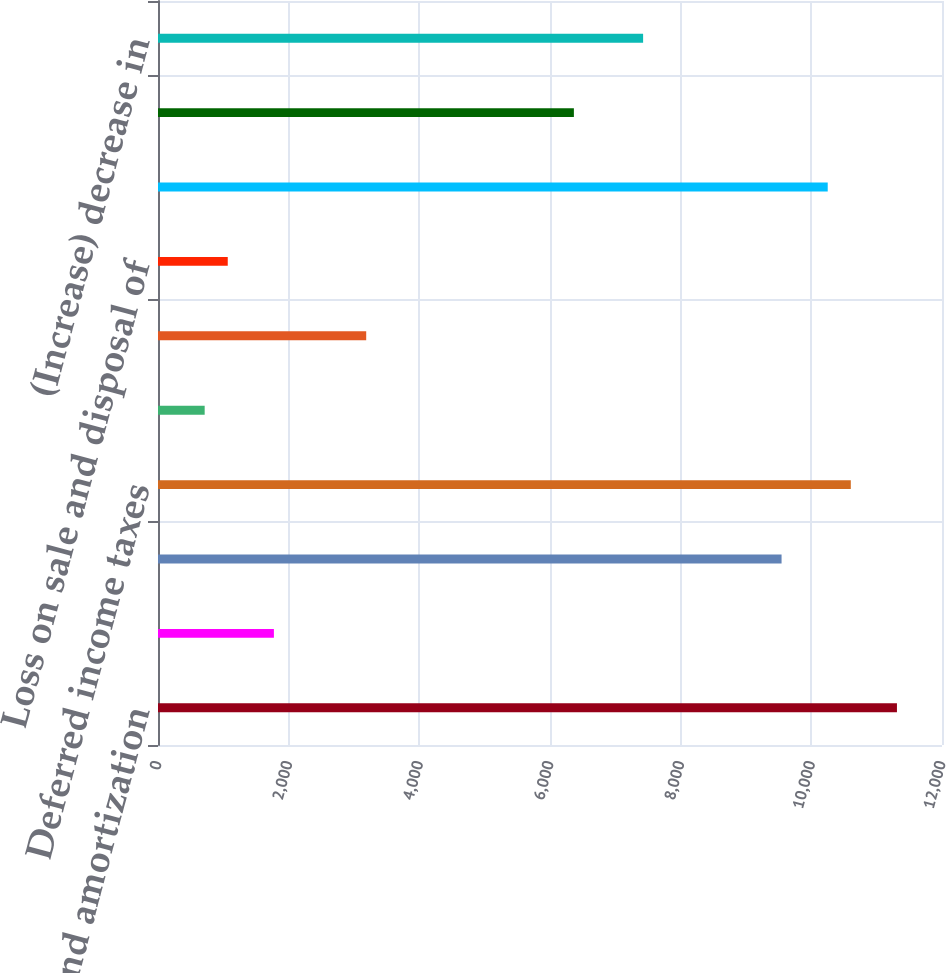Convert chart to OTSL. <chart><loc_0><loc_0><loc_500><loc_500><bar_chart><fcel>Depreciation and amortization<fcel>Loss (gain) on disposal and<fcel>Impairment expenses<fcel>Deferred income taxes<fcel>Provisions for contingencies<fcel>Loss on extinguishment of debt<fcel>Loss on sale and disposal of<fcel>Net loss (gain) from disposal<fcel>Other<fcel>(Increase) decrease in<nl><fcel>11310.4<fcel>1774<fcel>9544.4<fcel>10604<fcel>714.4<fcel>3186.8<fcel>1067.6<fcel>10250.8<fcel>6365.6<fcel>7425.2<nl></chart> 